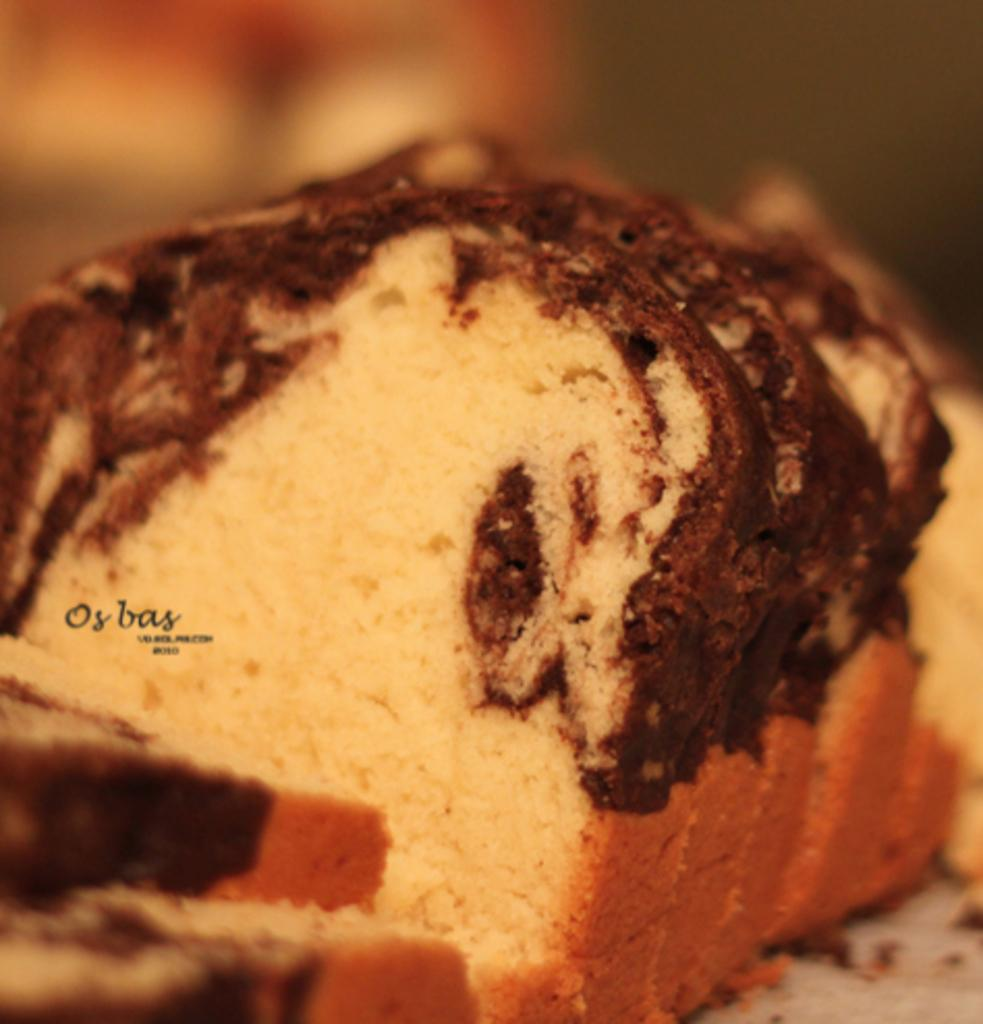What is the main subject of the image? The main subject of the image is bread slices. How are the bread slices positioned in the image? The bread slices are placed on a surface. What can be observed about the surroundings in the image? The surroundings of the image are blurred. Is there any additional information or marking on the image? Yes, there is a watermark on the left side of the image. What type of prison can be seen in the background of the image? There is no prison present in the image; it features a close-up view of bread slices with a blurred background. 